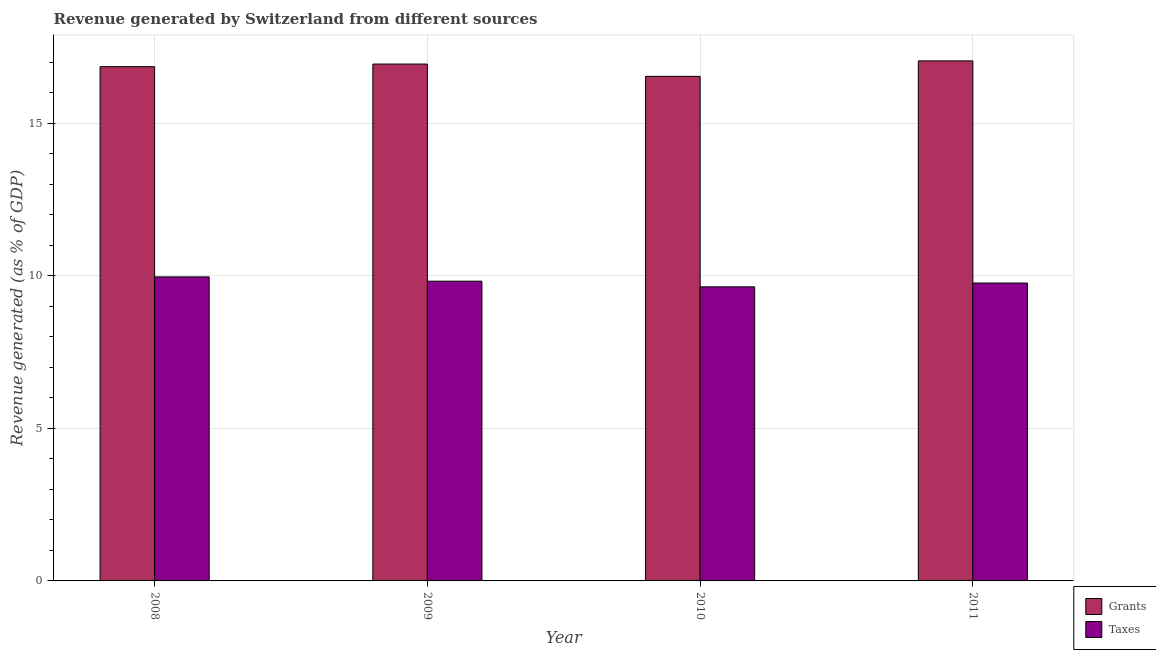How many different coloured bars are there?
Keep it short and to the point. 2. How many groups of bars are there?
Offer a terse response. 4. How many bars are there on the 1st tick from the left?
Ensure brevity in your answer.  2. How many bars are there on the 1st tick from the right?
Your answer should be compact. 2. What is the label of the 4th group of bars from the left?
Your answer should be compact. 2011. In how many cases, is the number of bars for a given year not equal to the number of legend labels?
Offer a very short reply. 0. What is the revenue generated by taxes in 2011?
Make the answer very short. 9.76. Across all years, what is the maximum revenue generated by grants?
Ensure brevity in your answer.  17.04. Across all years, what is the minimum revenue generated by grants?
Give a very brief answer. 16.53. In which year was the revenue generated by grants maximum?
Offer a terse response. 2011. What is the total revenue generated by grants in the graph?
Give a very brief answer. 67.35. What is the difference between the revenue generated by grants in 2008 and that in 2010?
Provide a short and direct response. 0.32. What is the difference between the revenue generated by taxes in 2011 and the revenue generated by grants in 2009?
Your answer should be very brief. -0.06. What is the average revenue generated by grants per year?
Your answer should be compact. 16.84. In the year 2011, what is the difference between the revenue generated by taxes and revenue generated by grants?
Make the answer very short. 0. What is the ratio of the revenue generated by grants in 2008 to that in 2011?
Keep it short and to the point. 0.99. Is the revenue generated by grants in 2008 less than that in 2009?
Your answer should be compact. Yes. What is the difference between the highest and the second highest revenue generated by grants?
Provide a short and direct response. 0.1. What is the difference between the highest and the lowest revenue generated by grants?
Give a very brief answer. 0.51. Is the sum of the revenue generated by taxes in 2008 and 2009 greater than the maximum revenue generated by grants across all years?
Your answer should be compact. Yes. What does the 1st bar from the left in 2008 represents?
Ensure brevity in your answer.  Grants. What does the 2nd bar from the right in 2011 represents?
Your answer should be very brief. Grants. How many bars are there?
Your answer should be very brief. 8. How many years are there in the graph?
Make the answer very short. 4. What is the difference between two consecutive major ticks on the Y-axis?
Your answer should be compact. 5. Does the graph contain any zero values?
Your answer should be very brief. No. What is the title of the graph?
Keep it short and to the point. Revenue generated by Switzerland from different sources. Does "Male entrants" appear as one of the legend labels in the graph?
Offer a very short reply. No. What is the label or title of the Y-axis?
Offer a terse response. Revenue generated (as % of GDP). What is the Revenue generated (as % of GDP) of Grants in 2008?
Keep it short and to the point. 16.85. What is the Revenue generated (as % of GDP) of Taxes in 2008?
Offer a terse response. 9.96. What is the Revenue generated (as % of GDP) of Grants in 2009?
Your response must be concise. 16.93. What is the Revenue generated (as % of GDP) in Taxes in 2009?
Your answer should be compact. 9.82. What is the Revenue generated (as % of GDP) of Grants in 2010?
Provide a succinct answer. 16.53. What is the Revenue generated (as % of GDP) in Taxes in 2010?
Provide a succinct answer. 9.63. What is the Revenue generated (as % of GDP) in Grants in 2011?
Give a very brief answer. 17.04. What is the Revenue generated (as % of GDP) in Taxes in 2011?
Offer a very short reply. 9.76. Across all years, what is the maximum Revenue generated (as % of GDP) in Grants?
Offer a terse response. 17.04. Across all years, what is the maximum Revenue generated (as % of GDP) of Taxes?
Provide a short and direct response. 9.96. Across all years, what is the minimum Revenue generated (as % of GDP) of Grants?
Make the answer very short. 16.53. Across all years, what is the minimum Revenue generated (as % of GDP) of Taxes?
Keep it short and to the point. 9.63. What is the total Revenue generated (as % of GDP) of Grants in the graph?
Provide a short and direct response. 67.35. What is the total Revenue generated (as % of GDP) in Taxes in the graph?
Provide a short and direct response. 39.17. What is the difference between the Revenue generated (as % of GDP) of Grants in 2008 and that in 2009?
Ensure brevity in your answer.  -0.09. What is the difference between the Revenue generated (as % of GDP) in Taxes in 2008 and that in 2009?
Ensure brevity in your answer.  0.14. What is the difference between the Revenue generated (as % of GDP) in Grants in 2008 and that in 2010?
Offer a very short reply. 0.32. What is the difference between the Revenue generated (as % of GDP) of Taxes in 2008 and that in 2010?
Give a very brief answer. 0.33. What is the difference between the Revenue generated (as % of GDP) of Grants in 2008 and that in 2011?
Make the answer very short. -0.19. What is the difference between the Revenue generated (as % of GDP) in Taxes in 2008 and that in 2011?
Give a very brief answer. 0.2. What is the difference between the Revenue generated (as % of GDP) of Grants in 2009 and that in 2010?
Provide a succinct answer. 0.4. What is the difference between the Revenue generated (as % of GDP) in Taxes in 2009 and that in 2010?
Offer a terse response. 0.19. What is the difference between the Revenue generated (as % of GDP) in Grants in 2009 and that in 2011?
Your response must be concise. -0.1. What is the difference between the Revenue generated (as % of GDP) in Taxes in 2009 and that in 2011?
Offer a terse response. 0.06. What is the difference between the Revenue generated (as % of GDP) in Grants in 2010 and that in 2011?
Your answer should be compact. -0.51. What is the difference between the Revenue generated (as % of GDP) in Taxes in 2010 and that in 2011?
Provide a short and direct response. -0.12. What is the difference between the Revenue generated (as % of GDP) in Grants in 2008 and the Revenue generated (as % of GDP) in Taxes in 2009?
Your answer should be compact. 7.03. What is the difference between the Revenue generated (as % of GDP) in Grants in 2008 and the Revenue generated (as % of GDP) in Taxes in 2010?
Your response must be concise. 7.21. What is the difference between the Revenue generated (as % of GDP) of Grants in 2008 and the Revenue generated (as % of GDP) of Taxes in 2011?
Give a very brief answer. 7.09. What is the difference between the Revenue generated (as % of GDP) of Grants in 2009 and the Revenue generated (as % of GDP) of Taxes in 2010?
Provide a succinct answer. 7.3. What is the difference between the Revenue generated (as % of GDP) in Grants in 2009 and the Revenue generated (as % of GDP) in Taxes in 2011?
Make the answer very short. 7.17. What is the difference between the Revenue generated (as % of GDP) of Grants in 2010 and the Revenue generated (as % of GDP) of Taxes in 2011?
Your answer should be compact. 6.77. What is the average Revenue generated (as % of GDP) in Grants per year?
Provide a short and direct response. 16.84. What is the average Revenue generated (as % of GDP) in Taxes per year?
Ensure brevity in your answer.  9.79. In the year 2008, what is the difference between the Revenue generated (as % of GDP) in Grants and Revenue generated (as % of GDP) in Taxes?
Offer a very short reply. 6.89. In the year 2009, what is the difference between the Revenue generated (as % of GDP) in Grants and Revenue generated (as % of GDP) in Taxes?
Provide a succinct answer. 7.11. In the year 2010, what is the difference between the Revenue generated (as % of GDP) of Grants and Revenue generated (as % of GDP) of Taxes?
Offer a very short reply. 6.9. In the year 2011, what is the difference between the Revenue generated (as % of GDP) of Grants and Revenue generated (as % of GDP) of Taxes?
Give a very brief answer. 7.28. What is the ratio of the Revenue generated (as % of GDP) in Grants in 2008 to that in 2009?
Make the answer very short. 0.99. What is the ratio of the Revenue generated (as % of GDP) in Taxes in 2008 to that in 2009?
Your answer should be very brief. 1.01. What is the ratio of the Revenue generated (as % of GDP) in Grants in 2008 to that in 2010?
Give a very brief answer. 1.02. What is the ratio of the Revenue generated (as % of GDP) of Taxes in 2008 to that in 2010?
Make the answer very short. 1.03. What is the ratio of the Revenue generated (as % of GDP) in Grants in 2008 to that in 2011?
Offer a very short reply. 0.99. What is the ratio of the Revenue generated (as % of GDP) of Taxes in 2008 to that in 2011?
Give a very brief answer. 1.02. What is the ratio of the Revenue generated (as % of GDP) in Grants in 2009 to that in 2010?
Ensure brevity in your answer.  1.02. What is the ratio of the Revenue generated (as % of GDP) in Taxes in 2009 to that in 2010?
Offer a terse response. 1.02. What is the ratio of the Revenue generated (as % of GDP) in Grants in 2010 to that in 2011?
Provide a succinct answer. 0.97. What is the ratio of the Revenue generated (as % of GDP) in Taxes in 2010 to that in 2011?
Give a very brief answer. 0.99. What is the difference between the highest and the second highest Revenue generated (as % of GDP) of Grants?
Your response must be concise. 0.1. What is the difference between the highest and the second highest Revenue generated (as % of GDP) of Taxes?
Your response must be concise. 0.14. What is the difference between the highest and the lowest Revenue generated (as % of GDP) in Grants?
Offer a terse response. 0.51. What is the difference between the highest and the lowest Revenue generated (as % of GDP) of Taxes?
Your response must be concise. 0.33. 